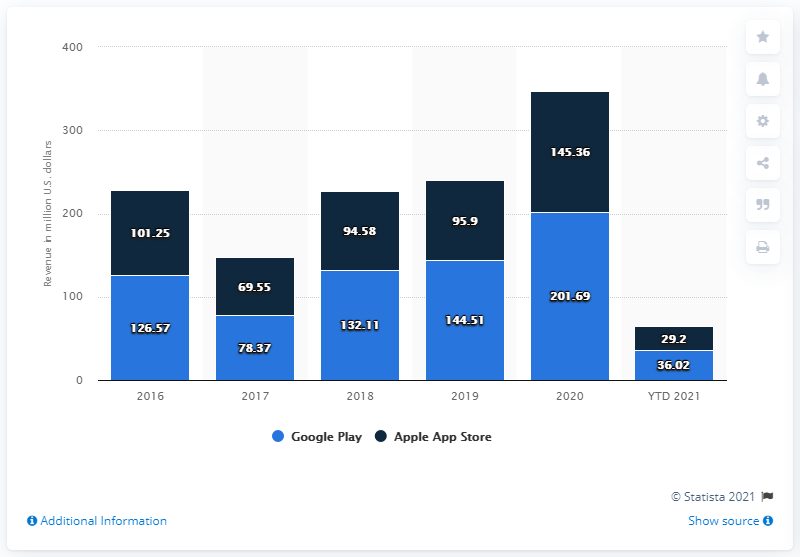Mention a couple of crucial points in this snapshot. The majority of Pokémon GO revenues are generated through Google Play. 